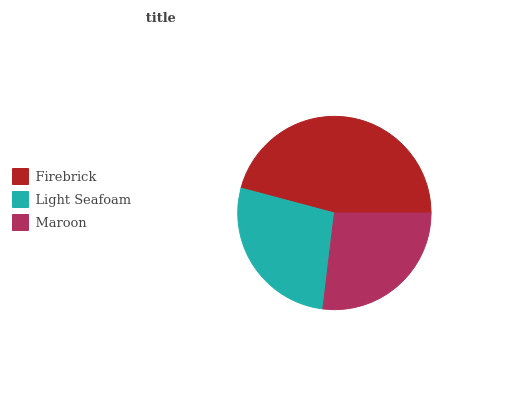Is Maroon the minimum?
Answer yes or no. Yes. Is Firebrick the maximum?
Answer yes or no. Yes. Is Light Seafoam the minimum?
Answer yes or no. No. Is Light Seafoam the maximum?
Answer yes or no. No. Is Firebrick greater than Light Seafoam?
Answer yes or no. Yes. Is Light Seafoam less than Firebrick?
Answer yes or no. Yes. Is Light Seafoam greater than Firebrick?
Answer yes or no. No. Is Firebrick less than Light Seafoam?
Answer yes or no. No. Is Light Seafoam the high median?
Answer yes or no. Yes. Is Light Seafoam the low median?
Answer yes or no. Yes. Is Maroon the high median?
Answer yes or no. No. Is Firebrick the low median?
Answer yes or no. No. 